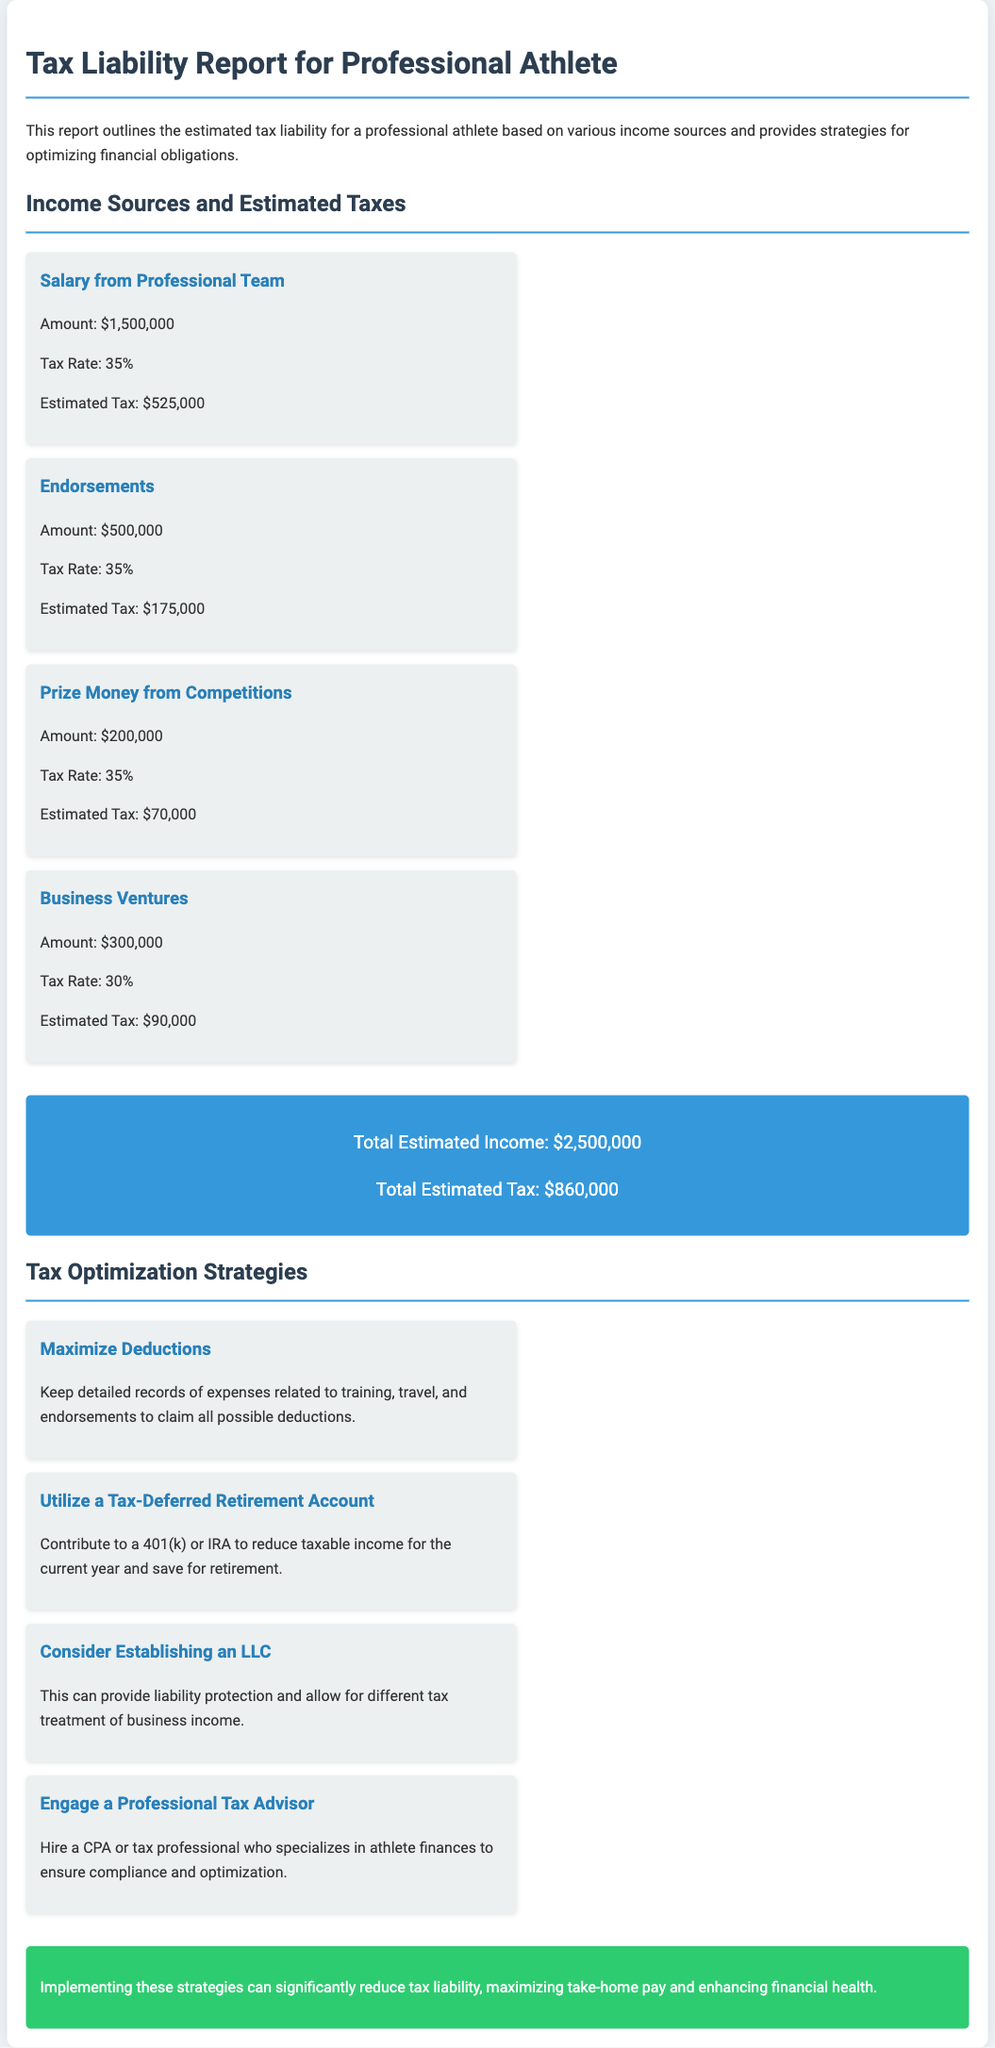What is the total estimated income? The total estimated income is mentioned in the document as the sum of all income sources, which is $2,500,000.
Answer: $2,500,000 What is the estimated tax for endorsements? The estimated tax for endorsements is calculated based on the endorsement amount and tax rate, which is $175,000.
Answer: $175,000 What tax rate applies to business ventures? The document specifies the tax rate for business ventures as 30%.
Answer: 30% Who can provide liability protection and different tax treatment of business income? The document suggests considering establishing an LLC for this purpose.
Answer: LLC What is one strategy for optimizing financial obligations? The document lists several strategies, one of which is to maximize deductions.
Answer: Maximize Deductions What is the total estimated tax amount? The total estimated tax amount is given as $860,000 in the document.
Answer: $860,000 What type of retirement account is suggested to reduce taxable income? The document mentions contributing to a 401(k) or IRA for this purpose.
Answer: 401(k) or IRA How can a professional tax advisor assist an athlete? The document states that a professional tax advisor can ensure compliance and optimization of tax matters.
Answer: Ensure compliance and optimization What is the consequence of implementing the suggested strategies? The document concludes that implementing these strategies can significantly reduce tax liability.
Answer: Significantly reduce tax liability 